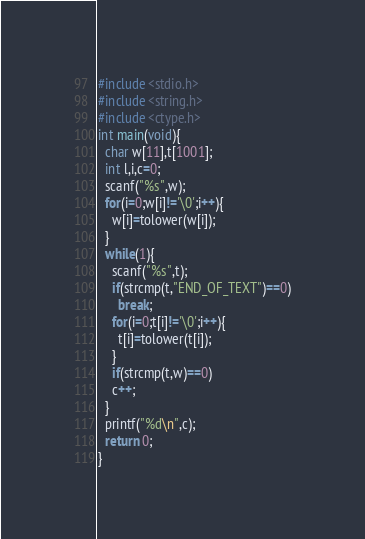Convert code to text. <code><loc_0><loc_0><loc_500><loc_500><_C_>#include <stdio.h>
#include <string.h>
#include <ctype.h>
int main(void){
  char w[11],t[1001];
  int l,i,c=0;
  scanf("%s",w);
  for(i=0;w[i]!='\0';i++){
    w[i]=tolower(w[i]);
  }
  while(1){
    scanf("%s",t);
    if(strcmp(t,"END_OF_TEXT")==0)
      break;
    for(i=0;t[i]!='\0';i++){
      t[i]=tolower(t[i]);
    }
    if(strcmp(t,w)==0)
    c++;
  }
  printf("%d\n",c);
  return 0;
}
</code> 